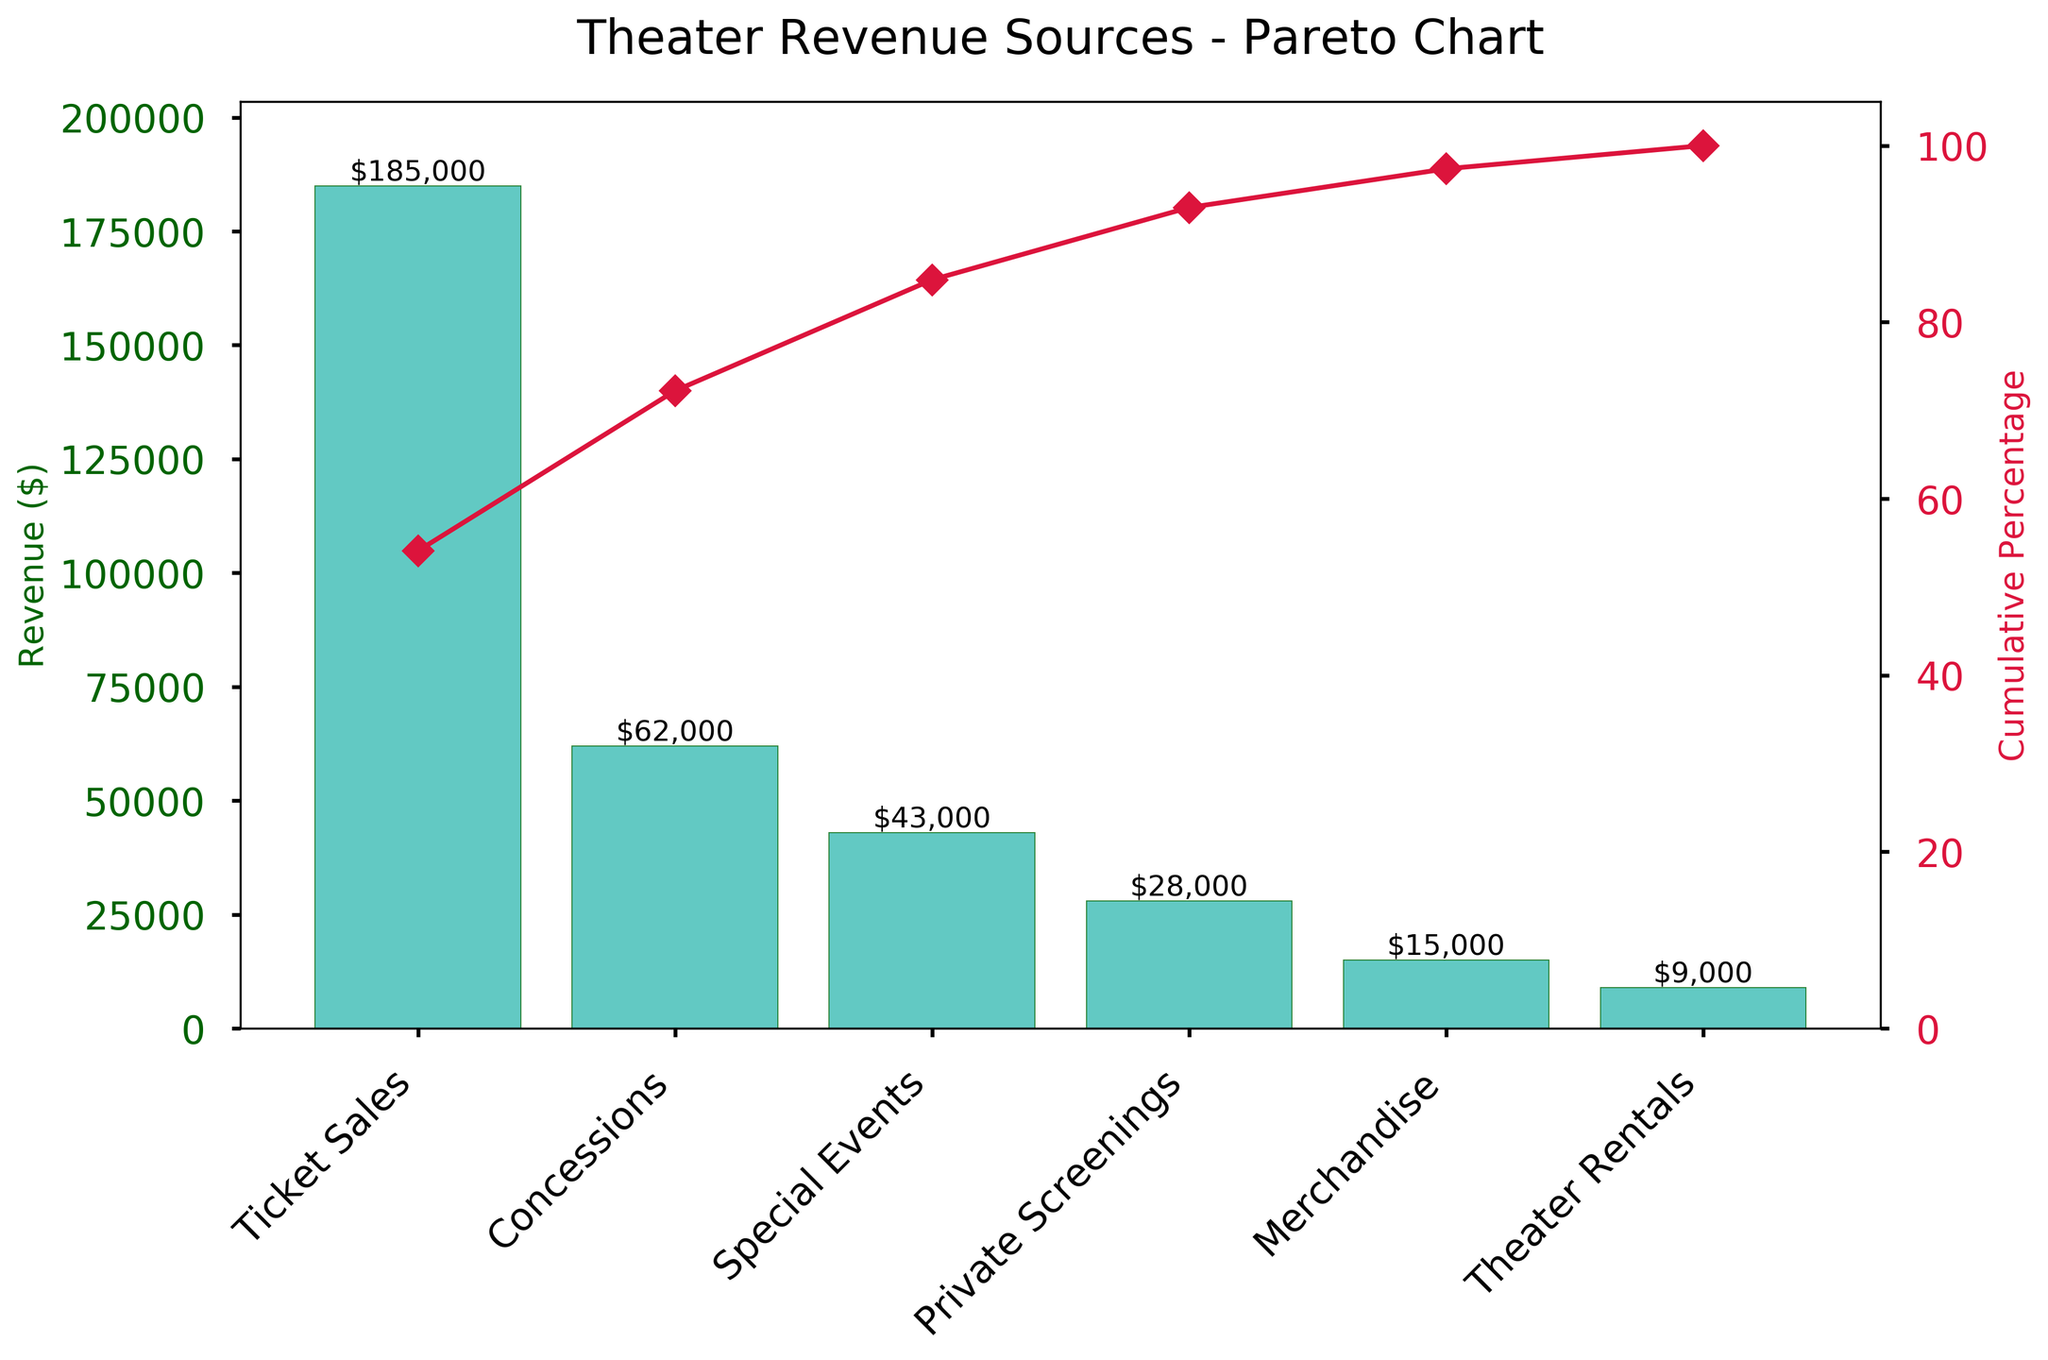What is the title of the chart? The title is located at the top of the figure, suggesting the main subject of the chart.
Answer: Theater Revenue Sources - Pareto Chart How much revenue did Ticket Sales generate? Refer to the bar height for Ticket Sales and the labeled value on the bar itself.
Answer: $185,000 What percentage of total revenue is contributed by Concessions? Locate the cumulative percentage line above the Concessions bar; the percentage shown represents the contribution of Concessions to total revenue.
Answer: Approximately 23% Which revenue source contributed the least to the total revenue? Identify the shortest bar and its corresponding label on the x-axis.
Answer: Theater Rentals What is the cumulative percentage after including Private Screenings? Follow the cumulative line up to the point where it includes Private Screenings and read the value on the right y-axis.
Answer: Approximately 87% How much more revenue did Ticket Sales generate compared to Special Events? Subtract the amount generated by Special Events from the amount generated by Ticket Sales: $185,000 - $43,000.
Answer: $142,000 Rank the revenue sources from highest to lowest. Observe and list the revenue sources in descending order based on the bar heights from left to right.
Answer: 1. Ticket Sales, 2. Concessions, 3. Special Events, 4. Private Screenings, 5. Merchandise, 6. Theater Rentals How much total revenue is generated by the theater? Sum the heights of all the bars to get the total revenue: $185,000 + $62,000 + $43,000 + $28,000 + $15,000 + $9,000.
Answer: $342,000 What is the cumulative percentage after including the first three revenue sources? Follow the cumulative percentage line up to the third data point (Special Events) and read the value on the right y-axis.
Answer: Approximately 84% Which revenue sources together contribute to more than 75% of the total revenue? Observe the cumulative percentage line and identify the bars that together surpass the 75% mark on the right y-axis.
Answer: Ticket Sales and Concessions 